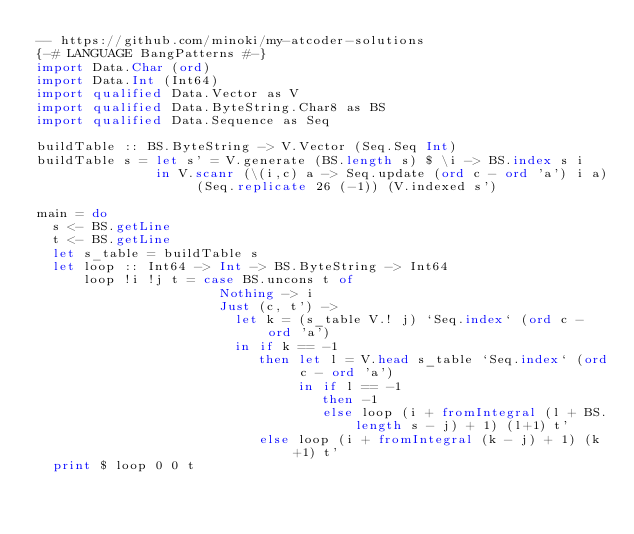Convert code to text. <code><loc_0><loc_0><loc_500><loc_500><_Haskell_>-- https://github.com/minoki/my-atcoder-solutions
{-# LANGUAGE BangPatterns #-}
import Data.Char (ord)
import Data.Int (Int64)
import qualified Data.Vector as V
import qualified Data.ByteString.Char8 as BS
import qualified Data.Sequence as Seq

buildTable :: BS.ByteString -> V.Vector (Seq.Seq Int)
buildTable s = let s' = V.generate (BS.length s) $ \i -> BS.index s i
               in V.scanr (\(i,c) a -> Seq.update (ord c - ord 'a') i a) (Seq.replicate 26 (-1)) (V.indexed s')

main = do
  s <- BS.getLine
  t <- BS.getLine
  let s_table = buildTable s
  let loop :: Int64 -> Int -> BS.ByteString -> Int64
      loop !i !j t = case BS.uncons t of
                       Nothing -> i
                       Just (c, t') ->
                         let k = (s_table V.! j) `Seq.index` (ord c - ord 'a')
                         in if k == -1
                            then let l = V.head s_table `Seq.index` (ord c - ord 'a')
                                 in if l == -1
                                    then -1
                                    else loop (i + fromIntegral (l + BS.length s - j) + 1) (l+1) t'
                            else loop (i + fromIntegral (k - j) + 1) (k+1) t'
  print $ loop 0 0 t
</code> 